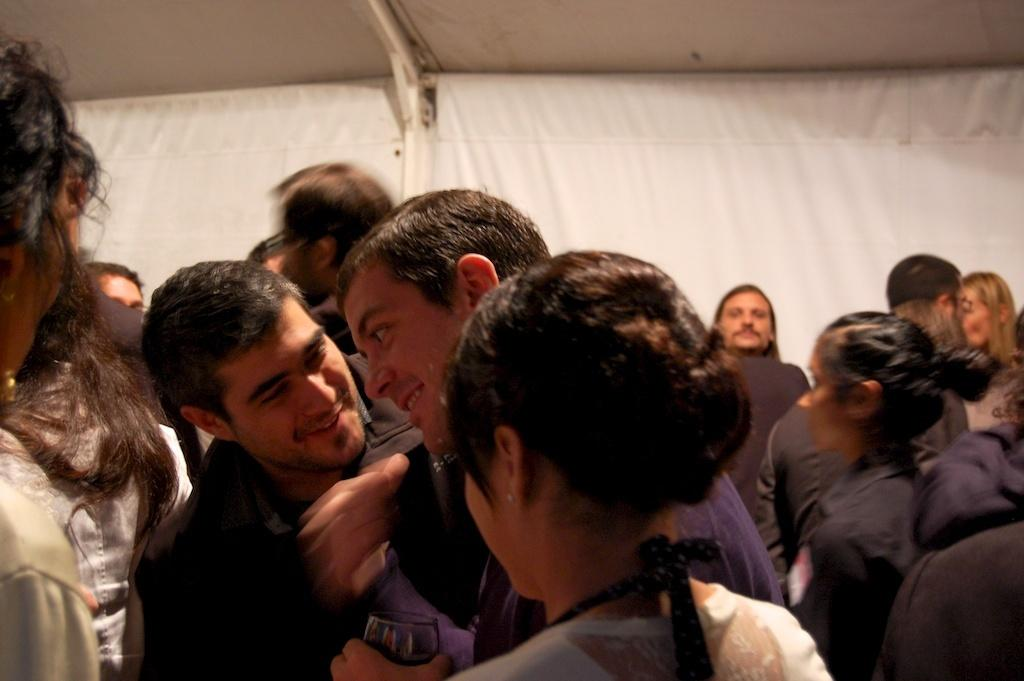How many people are in the image? There is a group of people in the image, but the exact number cannot be determined from the provided facts. What can be seen in the background of the image? There is a white color cloth in the background of the image. What type of pest can be seen crawling on the people in the image? There is no pest visible in the image; it only shows a group of people and a white color cloth in the background. 